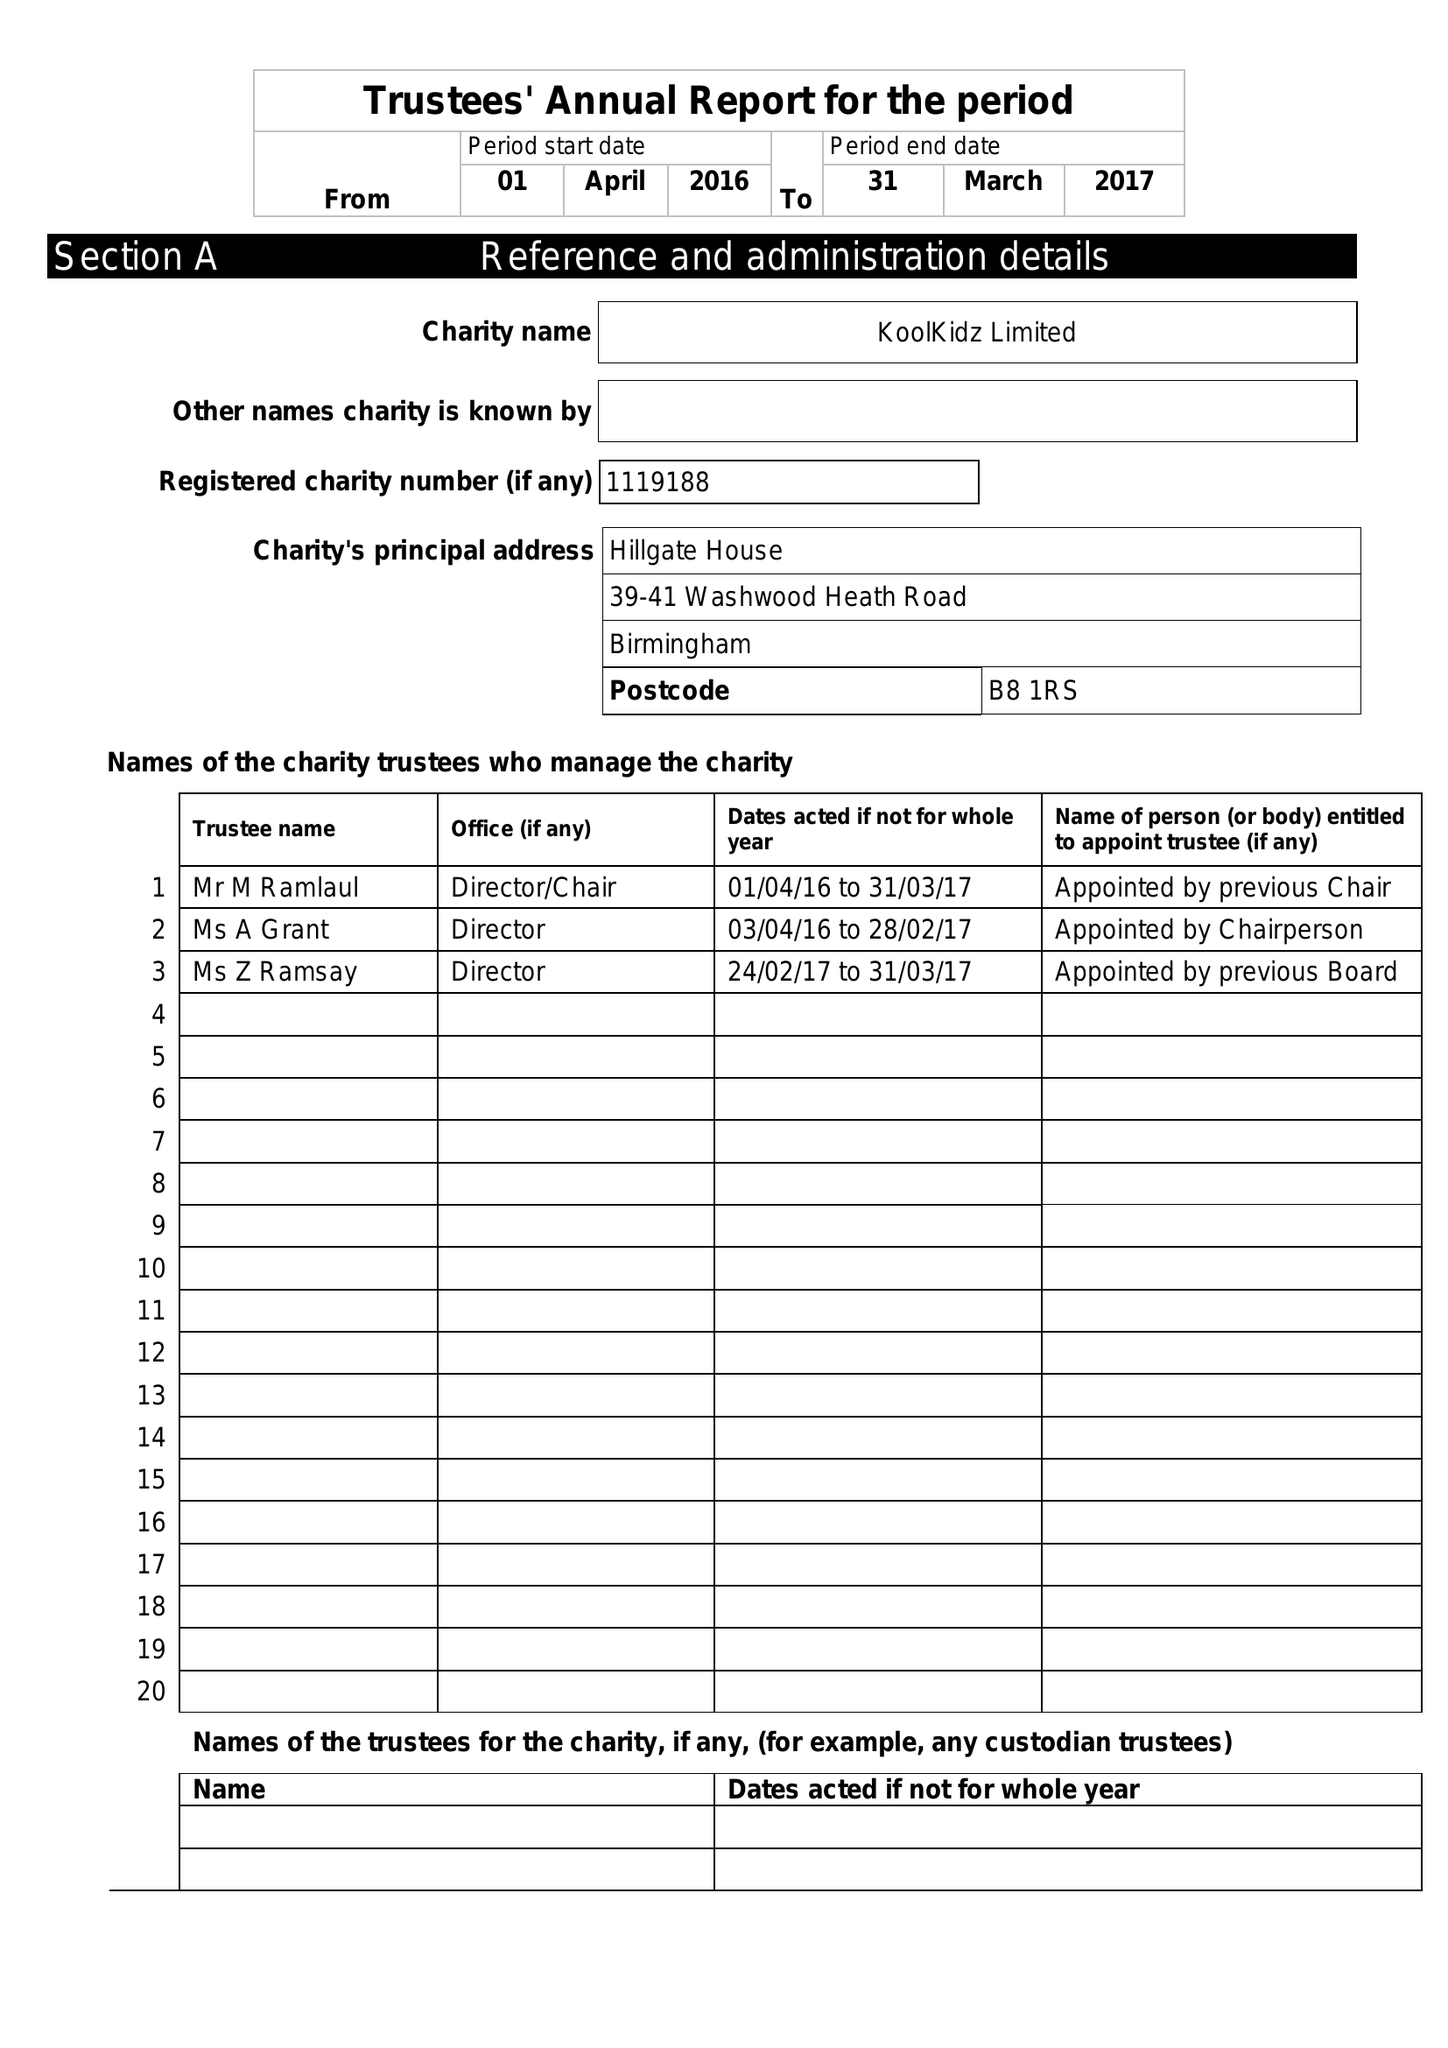What is the value for the address__street_line?
Answer the question using a single word or phrase. 39-41 WASHWOOD HEATH ROAD 